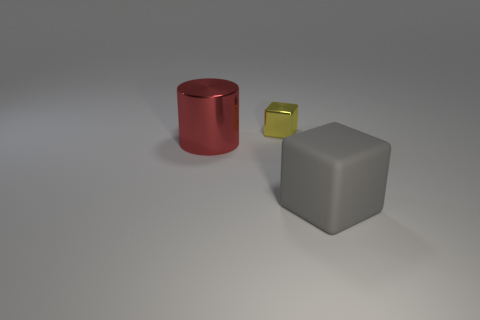Subtract all yellow blocks. How many blocks are left? 1 Subtract all cylinders. How many objects are left? 2 Subtract 1 cylinders. How many cylinders are left? 0 Add 2 tiny blue spheres. How many tiny blue spheres exist? 2 Add 3 red metallic cylinders. How many objects exist? 6 Subtract 0 cyan blocks. How many objects are left? 3 Subtract all yellow cylinders. Subtract all purple spheres. How many cylinders are left? 1 Subtract all gray balls. How many yellow blocks are left? 1 Subtract all large red spheres. Subtract all shiny blocks. How many objects are left? 2 Add 1 small yellow metallic things. How many small yellow metallic things are left? 2 